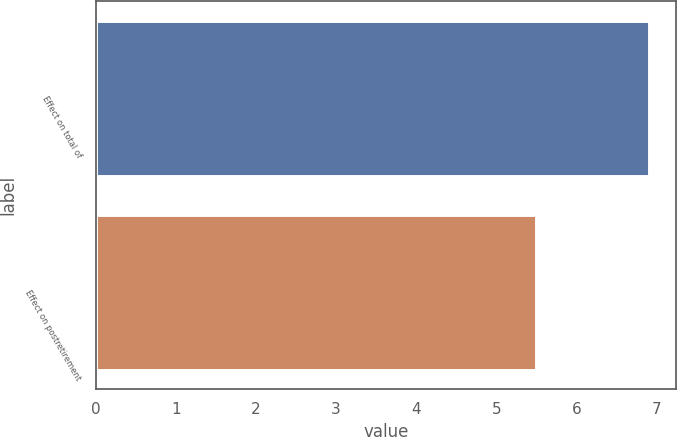Convert chart. <chart><loc_0><loc_0><loc_500><loc_500><bar_chart><fcel>Effect on total of<fcel>Effect on postretirement<nl><fcel>6.9<fcel>5.5<nl></chart> 